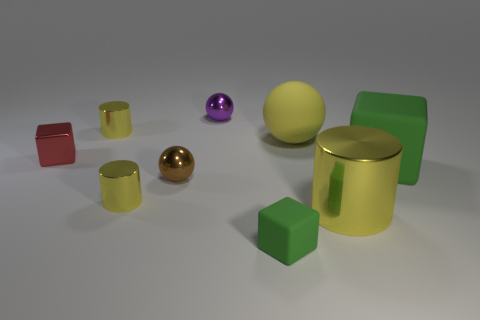What shape is the large matte thing that is the same color as the small rubber block?
Keep it short and to the point. Cube. There is a object that is both behind the large yellow cylinder and to the right of the big matte sphere; what material is it?
Make the answer very short. Rubber. Is the number of tiny cylinders less than the number of large rubber cylinders?
Provide a short and direct response. No. Is the shape of the small purple thing the same as the yellow shiny object to the right of the purple sphere?
Keep it short and to the point. No. Do the cube right of the yellow rubber object and the brown thing have the same size?
Provide a succinct answer. No. There is a green thing that is the same size as the brown thing; what shape is it?
Your answer should be very brief. Cube. Do the red metal object and the small brown thing have the same shape?
Offer a terse response. No. How many other brown metallic objects have the same shape as the brown object?
Offer a terse response. 0. How many green things are behind the tiny green block?
Make the answer very short. 1. Do the metal object that is right of the big yellow ball and the rubber sphere have the same color?
Your response must be concise. Yes. 